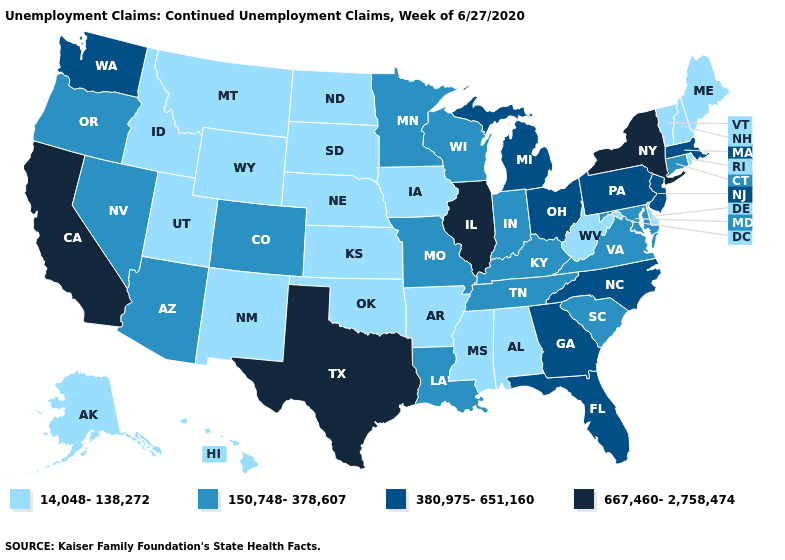What is the value of Illinois?
Short answer required. 667,460-2,758,474. What is the highest value in the MidWest ?
Be succinct. 667,460-2,758,474. Does Arizona have the lowest value in the West?
Quick response, please. No. What is the lowest value in states that border Illinois?
Answer briefly. 14,048-138,272. Does Rhode Island have the same value as Hawaii?
Quick response, please. Yes. What is the value of Michigan?
Concise answer only. 380,975-651,160. Does the map have missing data?
Quick response, please. No. What is the lowest value in the West?
Answer briefly. 14,048-138,272. Does the map have missing data?
Short answer required. No. What is the lowest value in the USA?
Quick response, please. 14,048-138,272. What is the highest value in the USA?
Answer briefly. 667,460-2,758,474. What is the value of Maine?
Concise answer only. 14,048-138,272. Which states hav the highest value in the Northeast?
Quick response, please. New York. Among the states that border Louisiana , does Texas have the lowest value?
Be succinct. No. Among the states that border Nebraska , which have the lowest value?
Be succinct. Iowa, Kansas, South Dakota, Wyoming. 